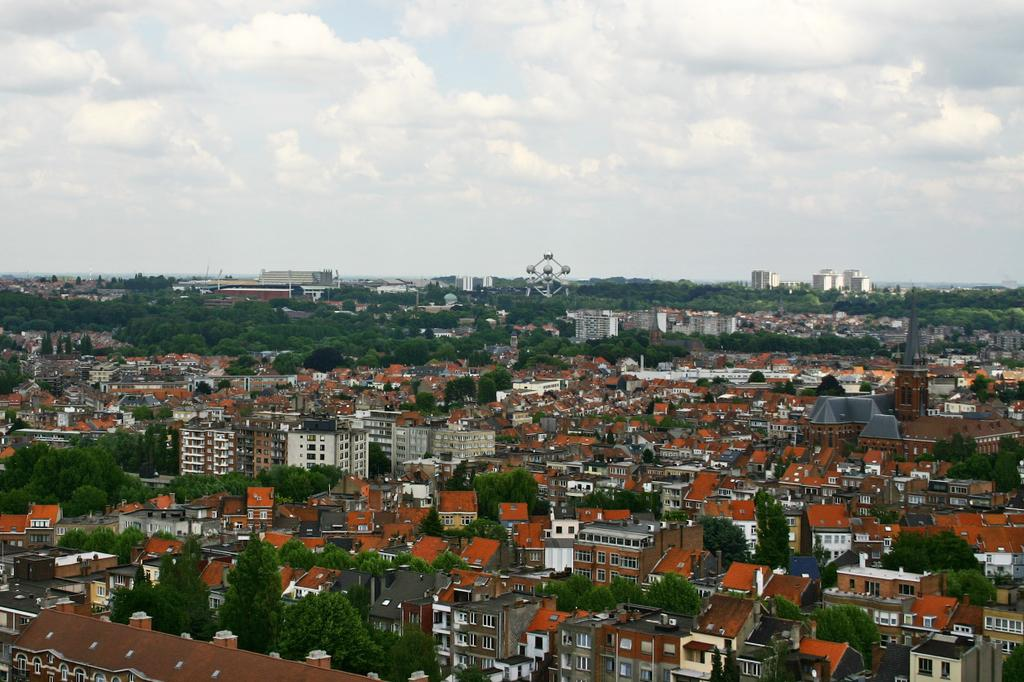What type of location is shown in the image? The image depicts a city. What types of structures can be seen in the city? There are houses and buildings in the city. Are there any natural elements present in the city? Yes, there are trees in the city. What is the condition of the sky in the image? The sky is clouded in the image. Can you see the cow's tongue sticking out in the image? There is no cow or tongue present in the image; it depicts a city with houses, buildings, trees, and a clouded sky. 